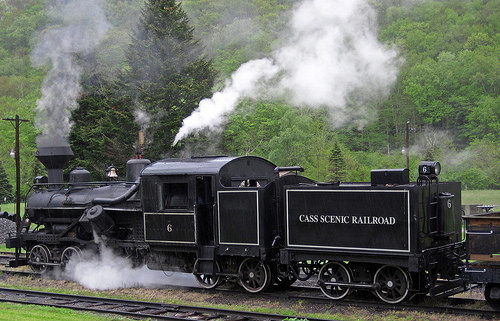<image>
Can you confirm if the train is under the steam? Yes. The train is positioned underneath the steam, with the steam above it in the vertical space. Where is the train in relation to the smoke? Is it next to the smoke? No. The train is not positioned next to the smoke. They are located in different areas of the scene. 